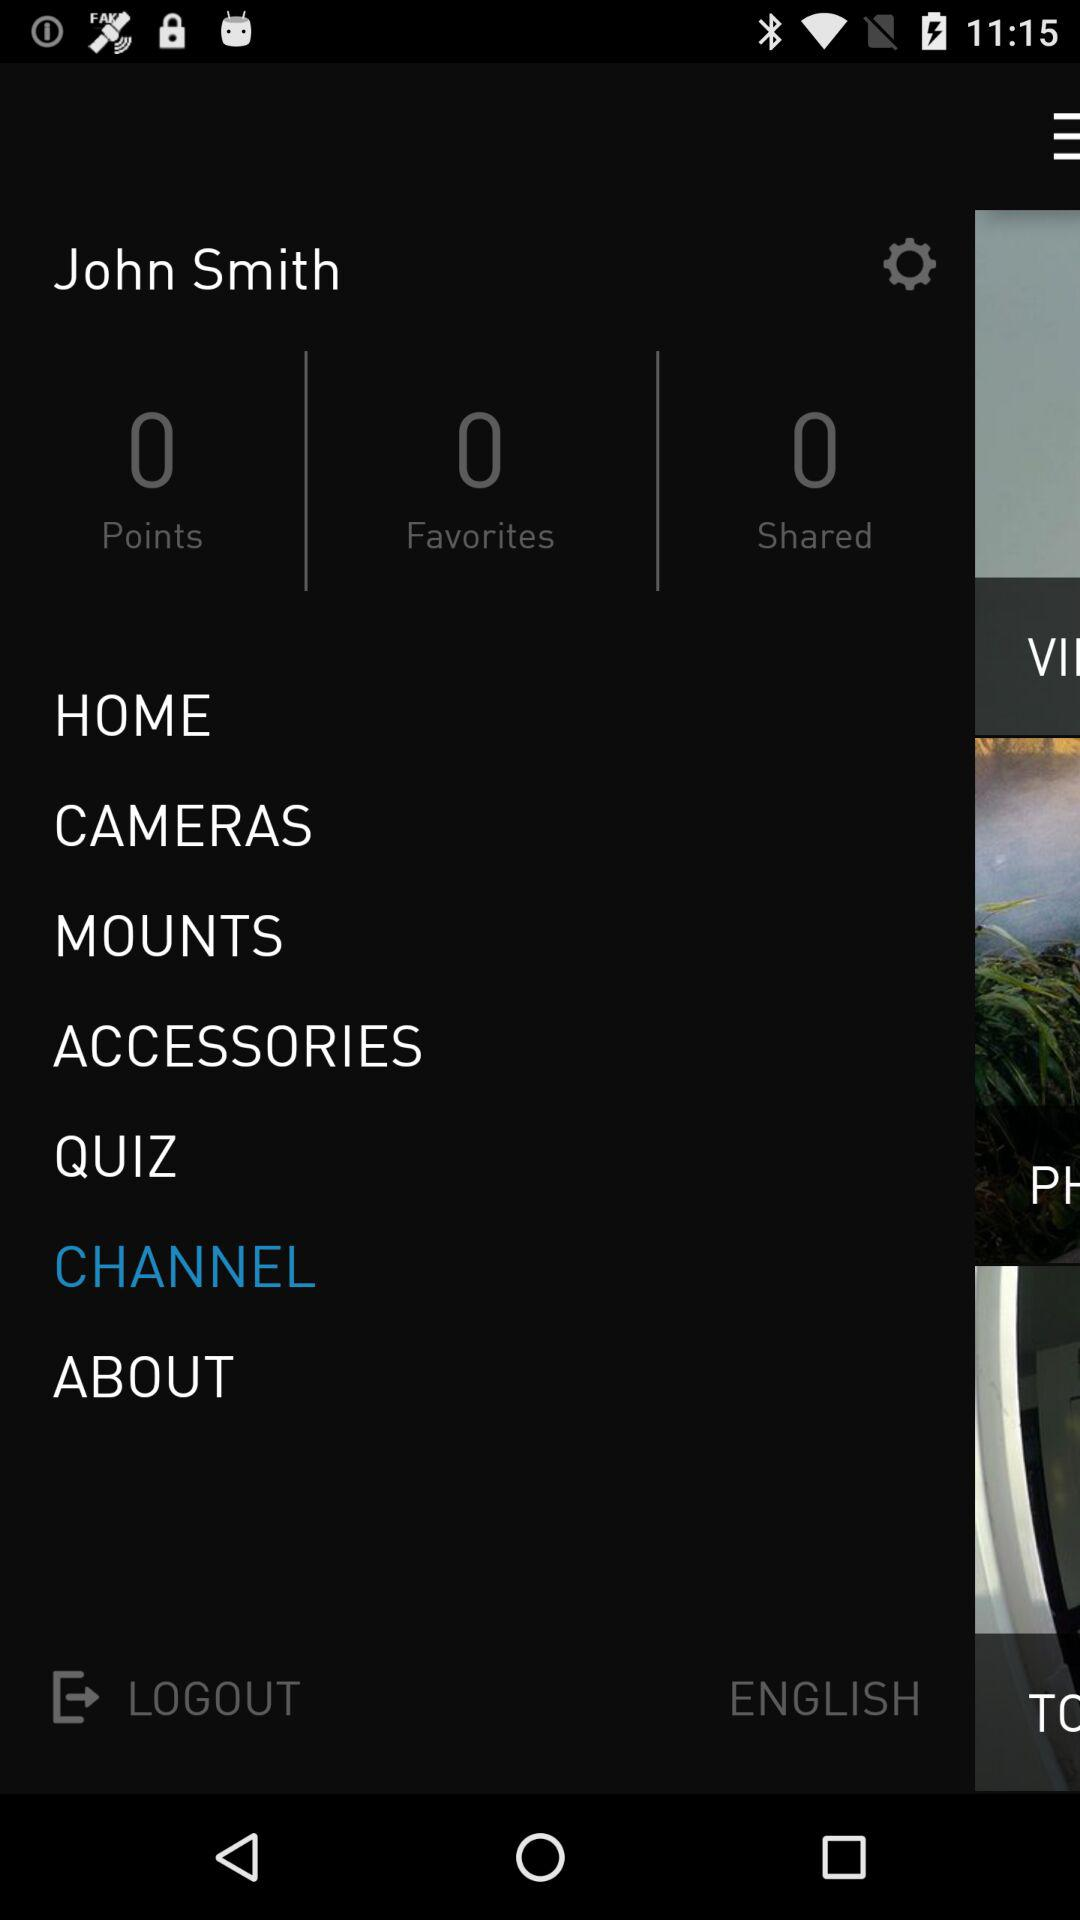What is the count for "Shared"? The count for "Shared" is 0. 